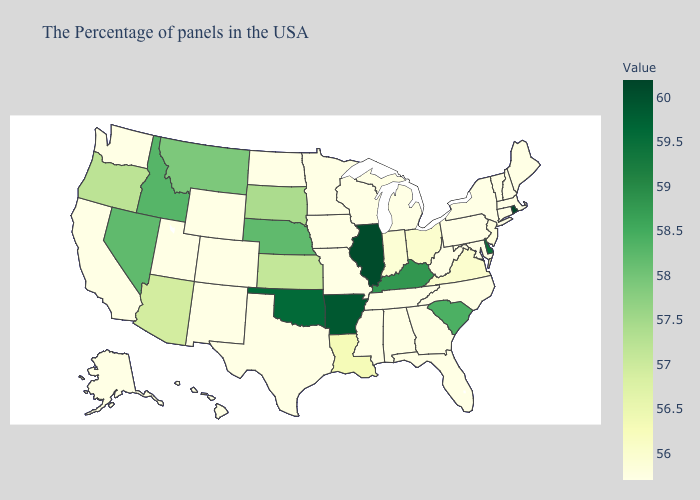Which states have the lowest value in the USA?
Concise answer only. Maine, Massachusetts, New Hampshire, Vermont, Connecticut, New York, Maryland, Pennsylvania, North Carolina, West Virginia, Florida, Georgia, Michigan, Alabama, Tennessee, Wisconsin, Mississippi, Missouri, Minnesota, Iowa, Texas, North Dakota, Wyoming, Colorado, New Mexico, Utah, California, Washington, Alaska, Hawaii. Which states have the highest value in the USA?
Answer briefly. Rhode Island. Does Iowa have the lowest value in the USA?
Quick response, please. Yes. 